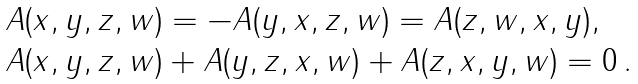<formula> <loc_0><loc_0><loc_500><loc_500>\begin{array} { l } A ( x , y , z , w ) = - A ( y , x , z , w ) = A ( z , w , x , y ) , \\ A ( x , y , z , w ) + A ( y , z , x , w ) + A ( z , x , y , w ) = 0 \, . \end{array}</formula> 